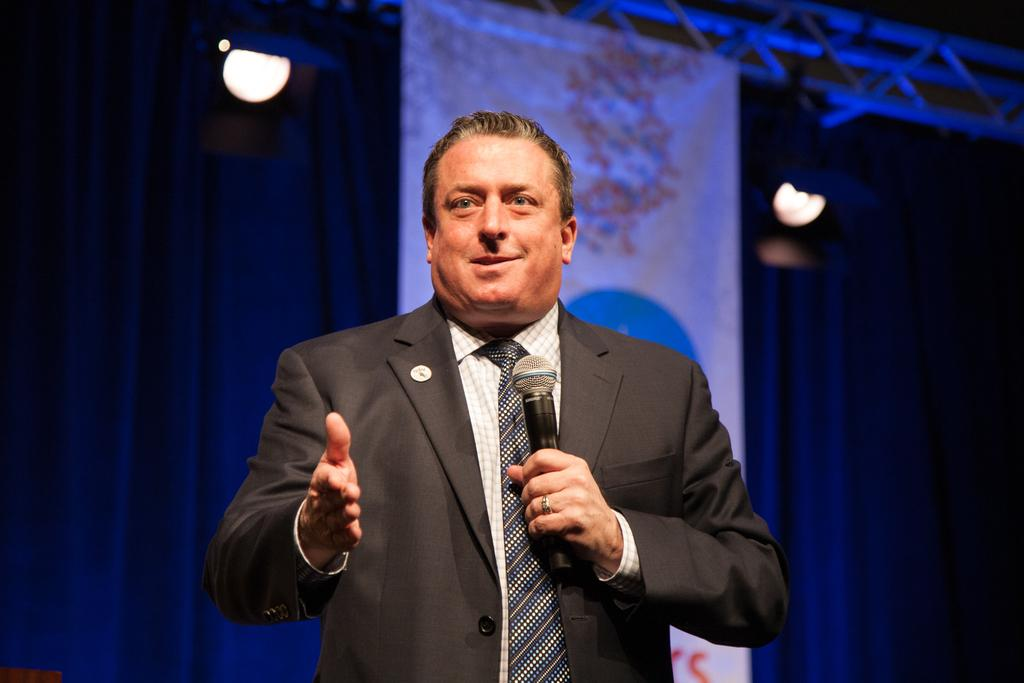What is the main subject in the foreground of the image? There is a man in the foreground of the image. What is the man holding in the image? The man is holding a mic. What can be seen in the background of the image? There is a curtain, lights, and a banner in the background of the image. What type of flowers can be seen in the image? There are no flowers present in the image. Is the man using a wrench or hammer in the image? There is no wrench or hammer present in the image; the man is holding a mic. 